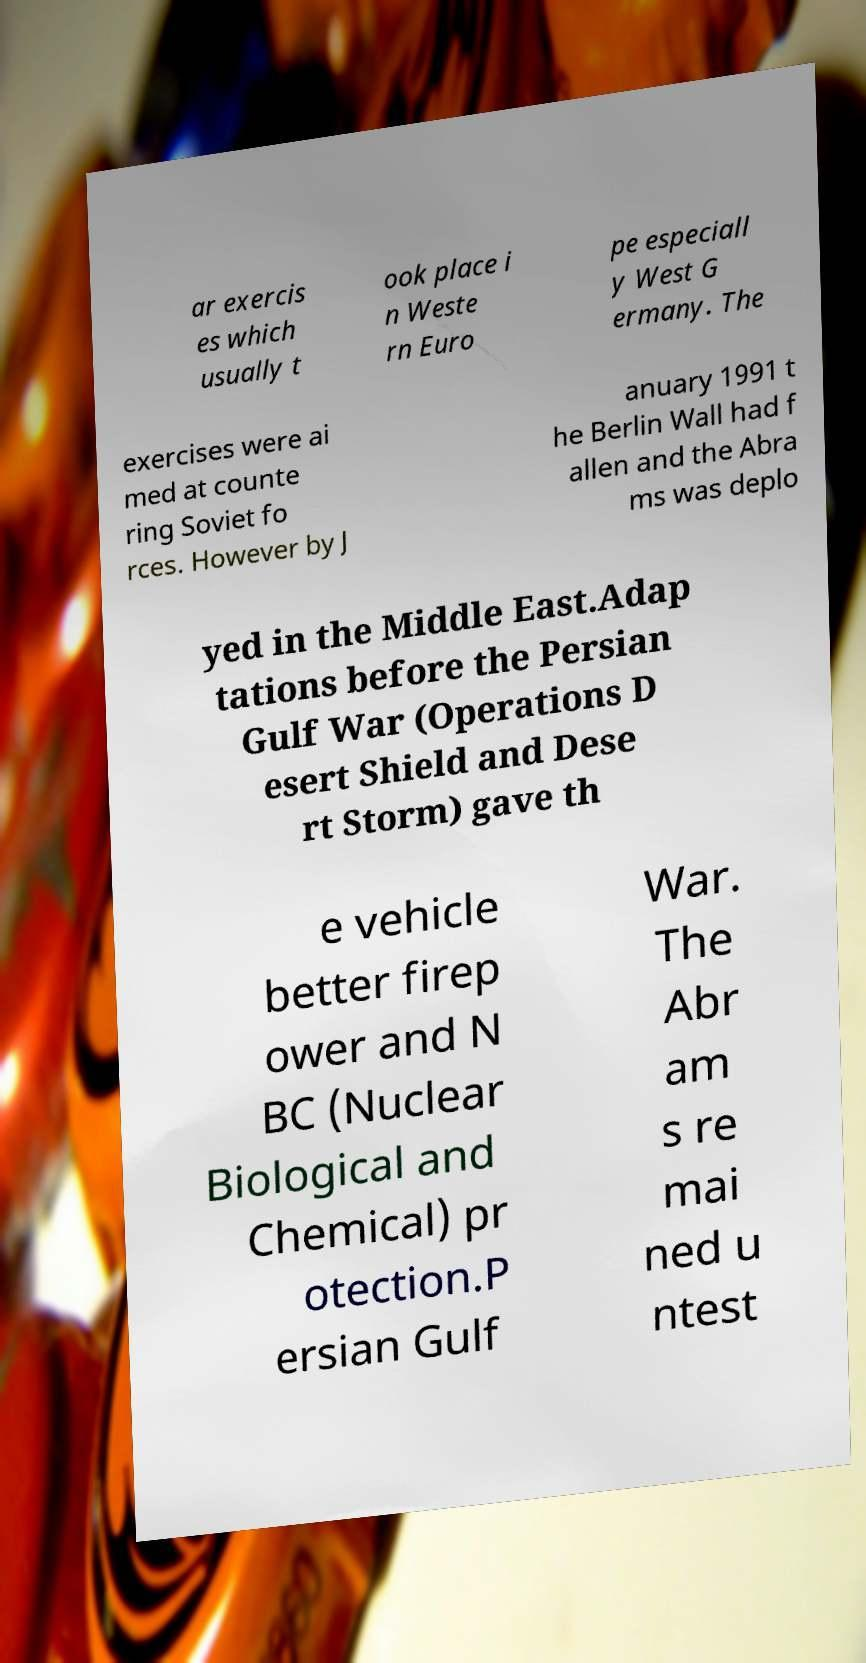Can you read and provide the text displayed in the image?This photo seems to have some interesting text. Can you extract and type it out for me? ar exercis es which usually t ook place i n Weste rn Euro pe especiall y West G ermany. The exercises were ai med at counte ring Soviet fo rces. However by J anuary 1991 t he Berlin Wall had f allen and the Abra ms was deplo yed in the Middle East.Adap tations before the Persian Gulf War (Operations D esert Shield and Dese rt Storm) gave th e vehicle better firep ower and N BC (Nuclear Biological and Chemical) pr otection.P ersian Gulf War. The Abr am s re mai ned u ntest 